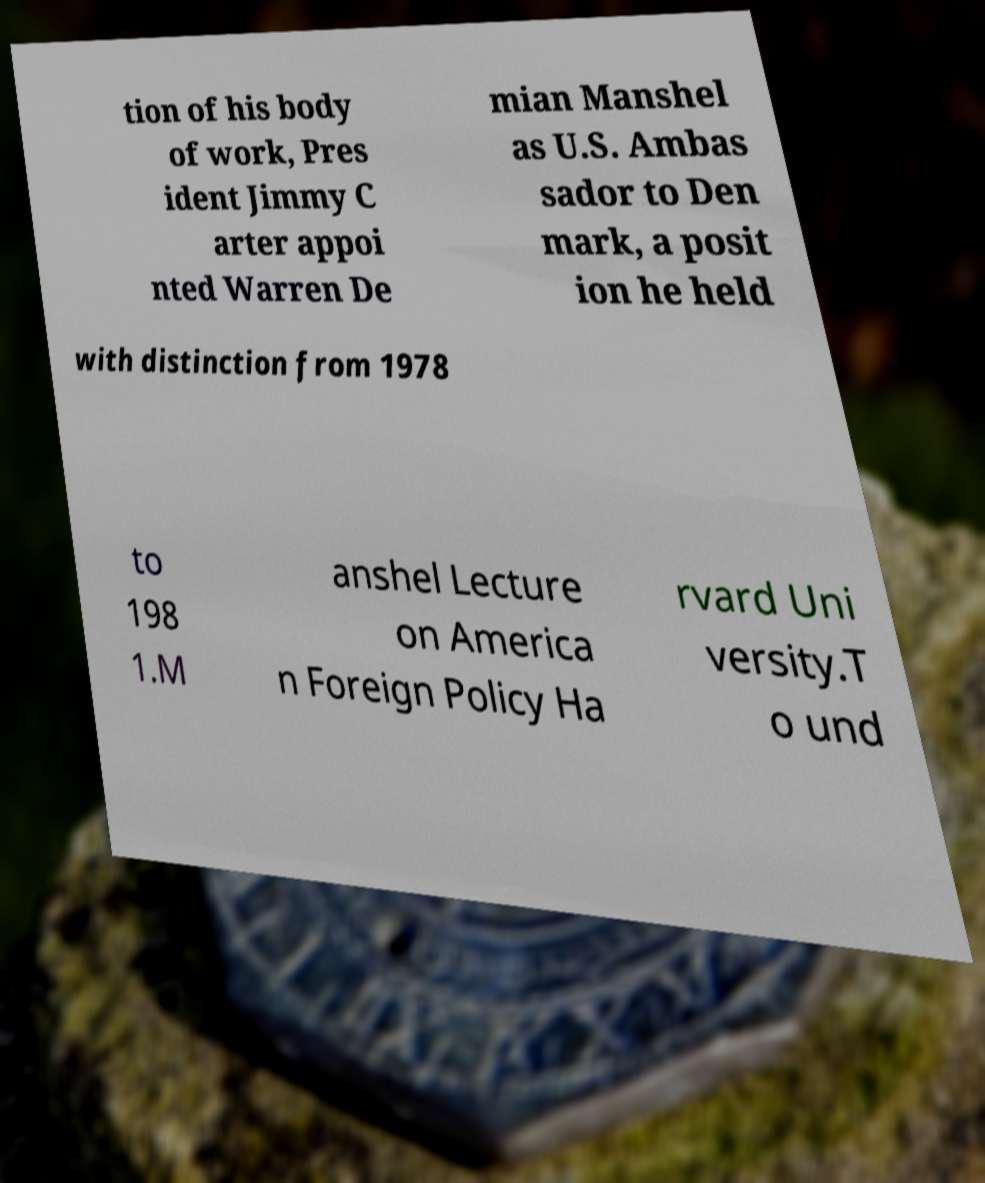Could you extract and type out the text from this image? tion of his body of work, Pres ident Jimmy C arter appoi nted Warren De mian Manshel as U.S. Ambas sador to Den mark, a posit ion he held with distinction from 1978 to 198 1.M anshel Lecture on America n Foreign Policy Ha rvard Uni versity.T o und 